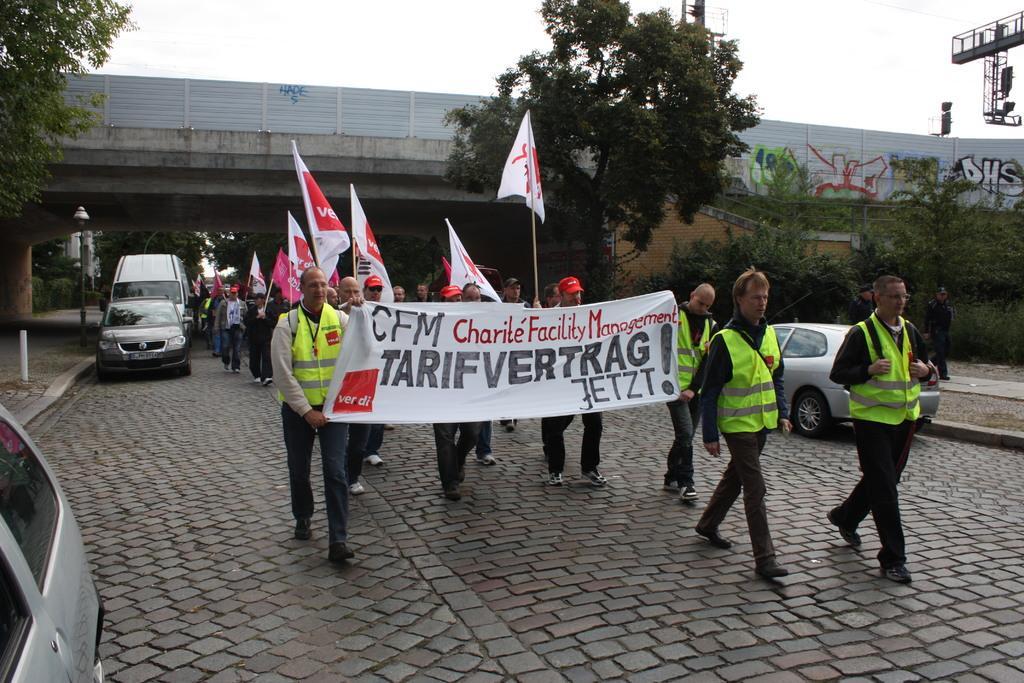In one or two sentences, can you explain what this image depicts? In the center of the image we can see a group of people are walking on the road and some of them are holding the flags and two men are holding a banner. In the background of the image we can see a bridge, graffiti on the wall, trees, vehicles, poles, light. At the bottom of the image we can see the road. At the top of the image we can see the sky. 